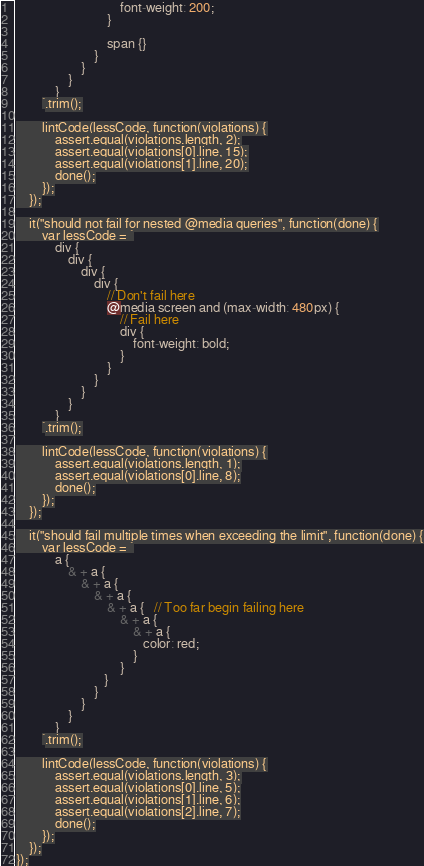<code> <loc_0><loc_0><loc_500><loc_500><_JavaScript_>                                font-weight: 200;
                            }

                            span {}
                        }
                    }
                }
            }
        `.trim();

        lintCode(lessCode, function(violations) {
            assert.equal(violations.length, 2);
            assert.equal(violations[0].line, 15);
            assert.equal(violations[1].line, 20);
            done();
        });
    });

    it("should not fail for nested @media queries", function(done) {
        var lessCode = `
            div {
                div {
                    div {
                        div {
                            // Don't fail here
                            @media screen and (max-width: 480px) {
                                // Fail here
                                div {
                                    font-weight: bold;
                                }
                            }
                        }
                    }
                }
            }
        `.trim();

        lintCode(lessCode, function(violations) {
            assert.equal(violations.length, 1);
            assert.equal(violations[0].line, 8);
            done();
        });
    });

    it("should fail multiple times when exceeding the limit", function(done) {
        var lessCode = `
            a {
                & + a {
                    & + a {
                        & + a {
                            & + a {   // Too far begin failing here
                                & + a {
                                    & + a {
                                       color: red;
                                    }
                                }
                           }
                        }
                    }
                }
            }
        `.trim();

        lintCode(lessCode, function(violations) {
            assert.equal(violations.length, 3);
            assert.equal(violations[0].line, 5);
            assert.equal(violations[1].line, 6);
            assert.equal(violations[2].line, 7);
            done();
        });
    });
});
</code> 